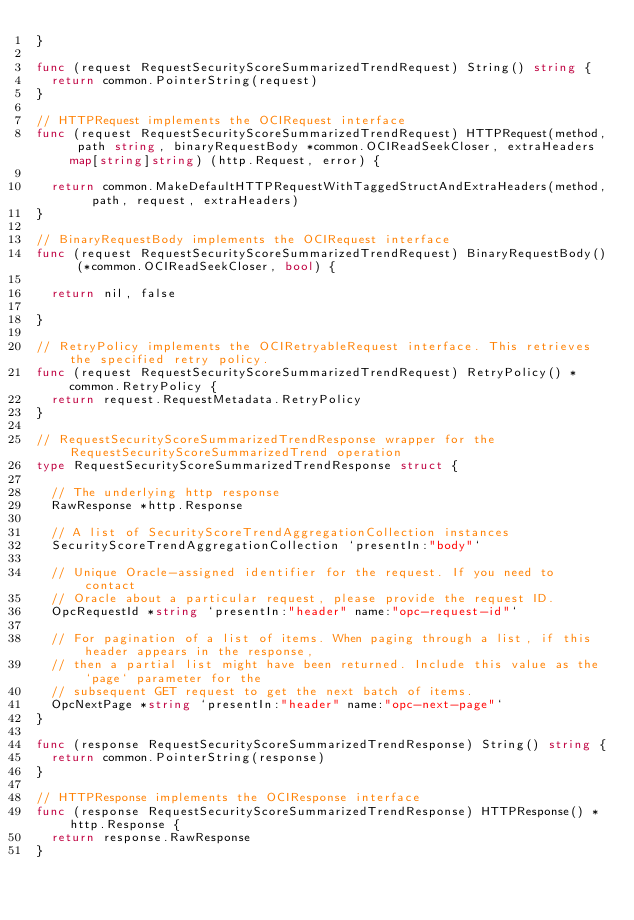Convert code to text. <code><loc_0><loc_0><loc_500><loc_500><_Go_>}

func (request RequestSecurityScoreSummarizedTrendRequest) String() string {
	return common.PointerString(request)
}

// HTTPRequest implements the OCIRequest interface
func (request RequestSecurityScoreSummarizedTrendRequest) HTTPRequest(method, path string, binaryRequestBody *common.OCIReadSeekCloser, extraHeaders map[string]string) (http.Request, error) {

	return common.MakeDefaultHTTPRequestWithTaggedStructAndExtraHeaders(method, path, request, extraHeaders)
}

// BinaryRequestBody implements the OCIRequest interface
func (request RequestSecurityScoreSummarizedTrendRequest) BinaryRequestBody() (*common.OCIReadSeekCloser, bool) {

	return nil, false

}

// RetryPolicy implements the OCIRetryableRequest interface. This retrieves the specified retry policy.
func (request RequestSecurityScoreSummarizedTrendRequest) RetryPolicy() *common.RetryPolicy {
	return request.RequestMetadata.RetryPolicy
}

// RequestSecurityScoreSummarizedTrendResponse wrapper for the RequestSecurityScoreSummarizedTrend operation
type RequestSecurityScoreSummarizedTrendResponse struct {

	// The underlying http response
	RawResponse *http.Response

	// A list of SecurityScoreTrendAggregationCollection instances
	SecurityScoreTrendAggregationCollection `presentIn:"body"`

	// Unique Oracle-assigned identifier for the request. If you need to contact
	// Oracle about a particular request, please provide the request ID.
	OpcRequestId *string `presentIn:"header" name:"opc-request-id"`

	// For pagination of a list of items. When paging through a list, if this header appears in the response,
	// then a partial list might have been returned. Include this value as the `page` parameter for the
	// subsequent GET request to get the next batch of items.
	OpcNextPage *string `presentIn:"header" name:"opc-next-page"`
}

func (response RequestSecurityScoreSummarizedTrendResponse) String() string {
	return common.PointerString(response)
}

// HTTPResponse implements the OCIResponse interface
func (response RequestSecurityScoreSummarizedTrendResponse) HTTPResponse() *http.Response {
	return response.RawResponse
}
</code> 